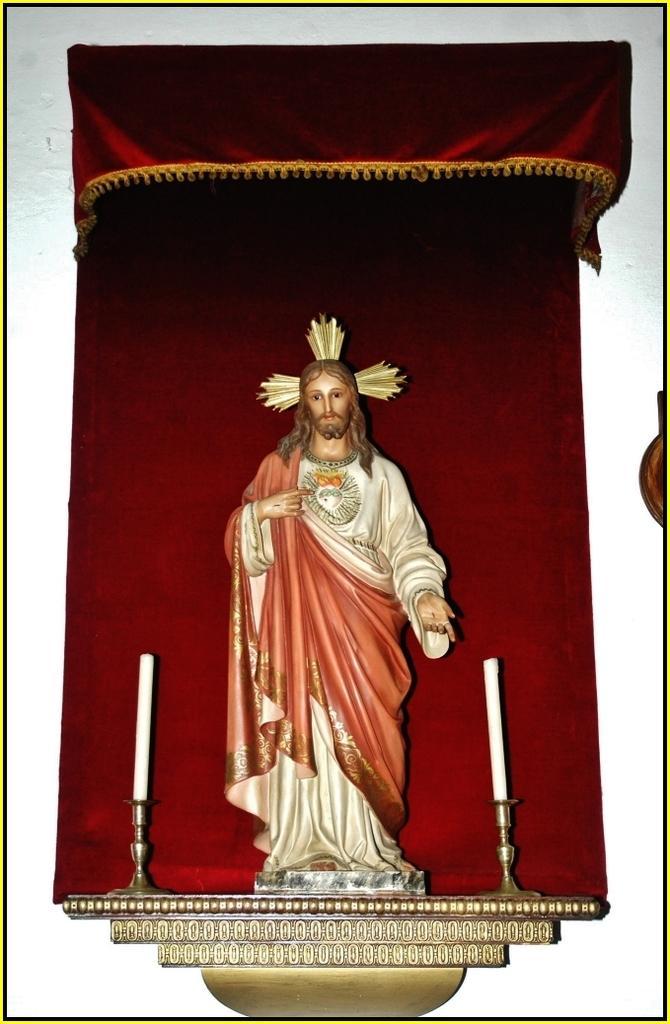How would you summarize this image in a sentence or two? In the center of the image there is a statue. On both sides of the statue there is a candle. In the background there is a wall. 